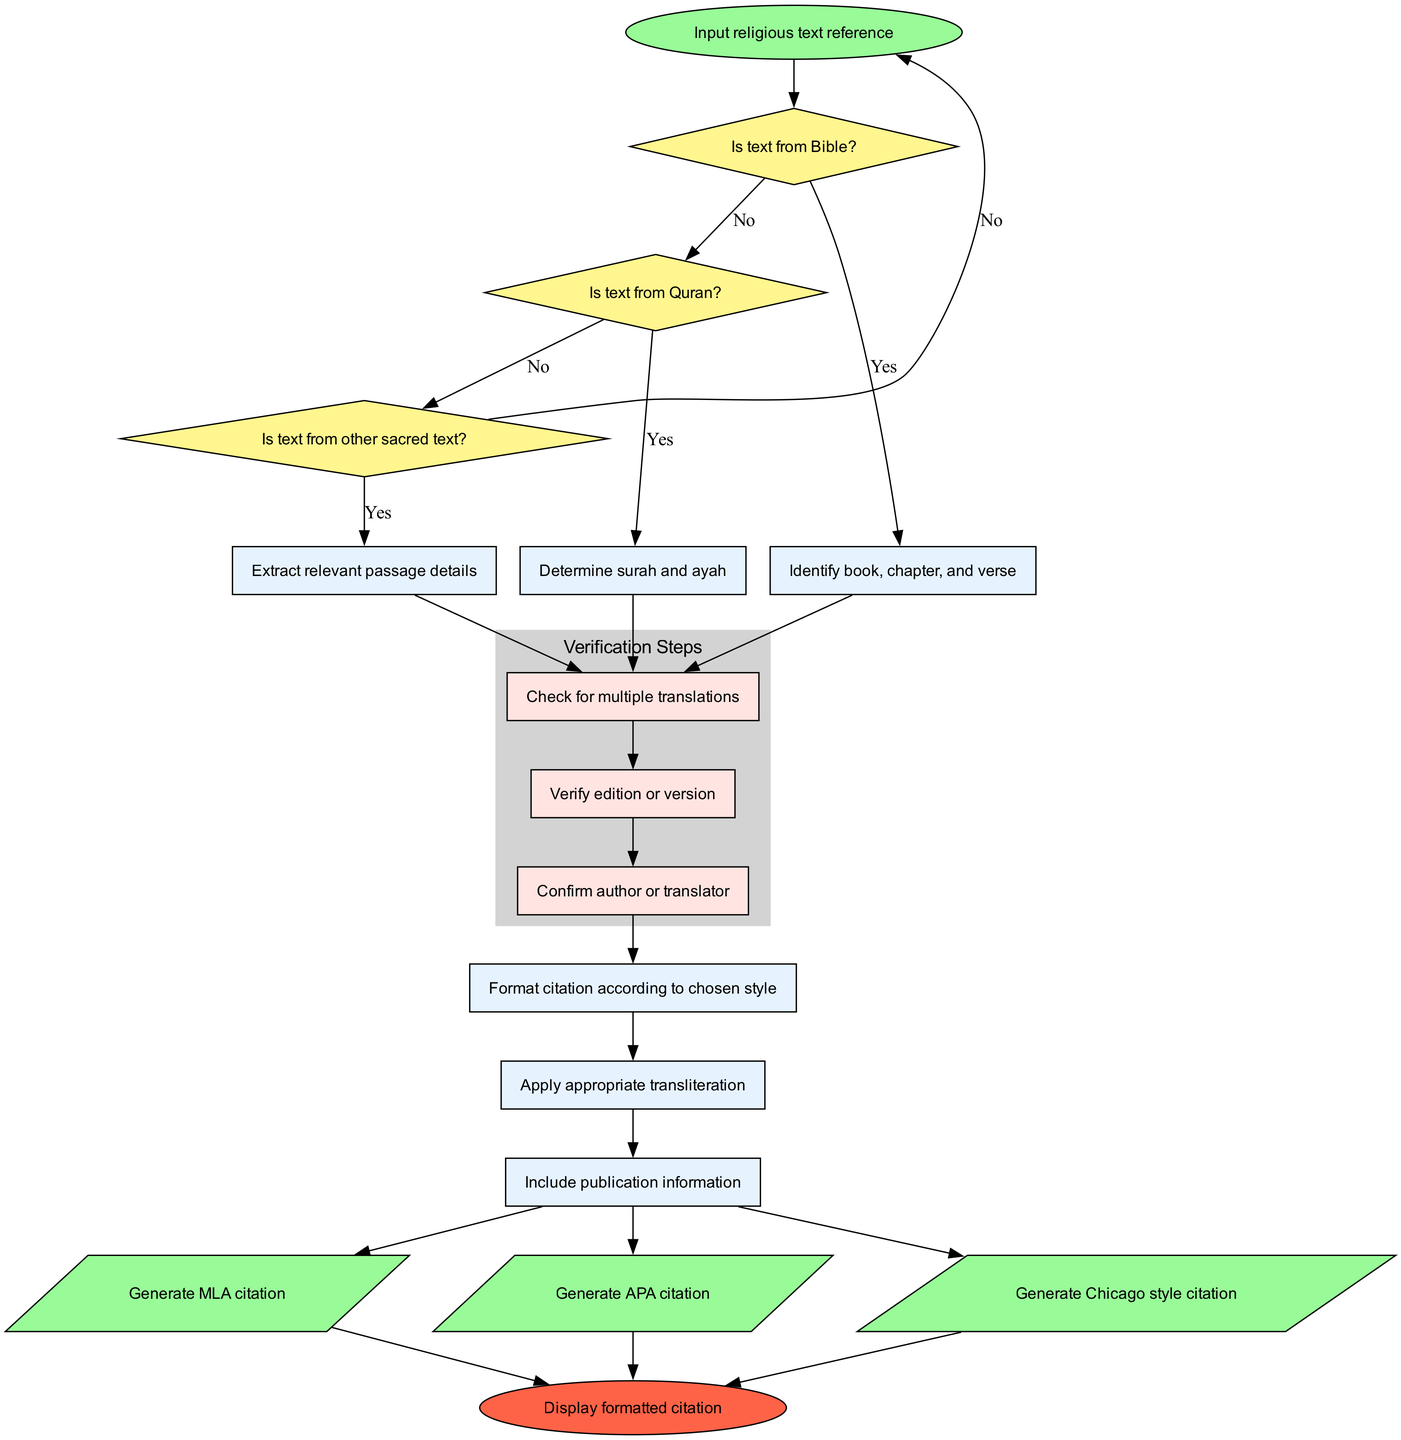What is the first action taken in the flowchart? The diagram starts with the action labeled "Input religious text reference." This indicates that the process begins by receiving a reference to a religious text.
Answer: Input religious text reference How many decision nodes are in the flowchart? There are three decision nodes present in the flowchart, each representing a question about the type of religious text: Bible, Quran, and other sacred text.
Answer: 3 What is the output after processing a text from the Bible? After identifying that the text is from the Bible, the flow proceeds to the process of identifying the book, chapter, and verse, leading ultimately to generating citations.
Answer: Generate MLA citation What subprocesses are involved in the verification step? The verification steps include checking for multiple translations, verifying edition or version, and confirming author or translator. Each subprocess is necessary to ensure citation accuracy.
Answer: Check for multiple translations, verify edition or version, confirm author or translator What happens if the text does not belong to any sacred text? If the text does not belong to the categories of Bible, Quran, or other sacred texts, the flow leads back to the start node without producing a citation, indicating that there’s no valid text to process.
Answer: Return to start Which citation styles are generated as outputs? The flowchart generates three citation styles as outputs: MLA, APA, and Chicago style. Each output represents a formatting style for the citations based on the processed reference.
Answer: MLA citation, APA citation, Chicago style citation What is the last step before reaching the end node? The last step before reaching the end node involves displaying the formatted citation, meaning that the citation has been successfully generated according to the specified format.
Answer: Display formatted citation Which node represents a process involved in formatting the citation? The node labeled "Format citation according to chosen style" represents a crucial process in the flowchart responsible for formatting the generated citations based on the user’s preference.
Answer: Format citation according to chosen style What is the shape of the start node in the diagram? The start node is shaped like an oval, which is a common representation for the starting point in a flowchart, indicating where the flow begins.
Answer: Oval 